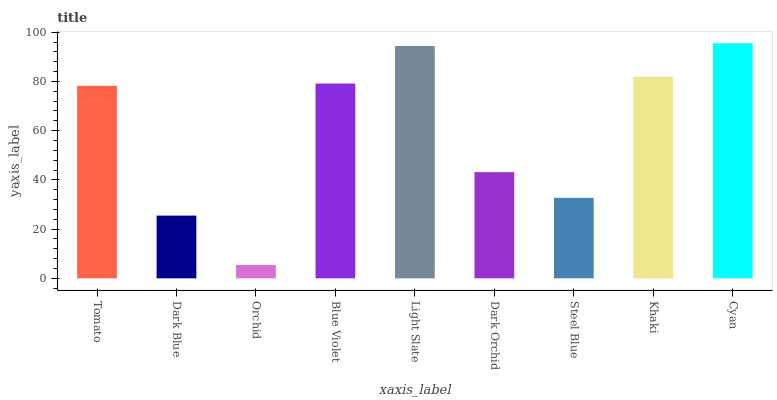Is Orchid the minimum?
Answer yes or no. Yes. Is Cyan the maximum?
Answer yes or no. Yes. Is Dark Blue the minimum?
Answer yes or no. No. Is Dark Blue the maximum?
Answer yes or no. No. Is Tomato greater than Dark Blue?
Answer yes or no. Yes. Is Dark Blue less than Tomato?
Answer yes or no. Yes. Is Dark Blue greater than Tomato?
Answer yes or no. No. Is Tomato less than Dark Blue?
Answer yes or no. No. Is Tomato the high median?
Answer yes or no. Yes. Is Tomato the low median?
Answer yes or no. Yes. Is Light Slate the high median?
Answer yes or no. No. Is Cyan the low median?
Answer yes or no. No. 